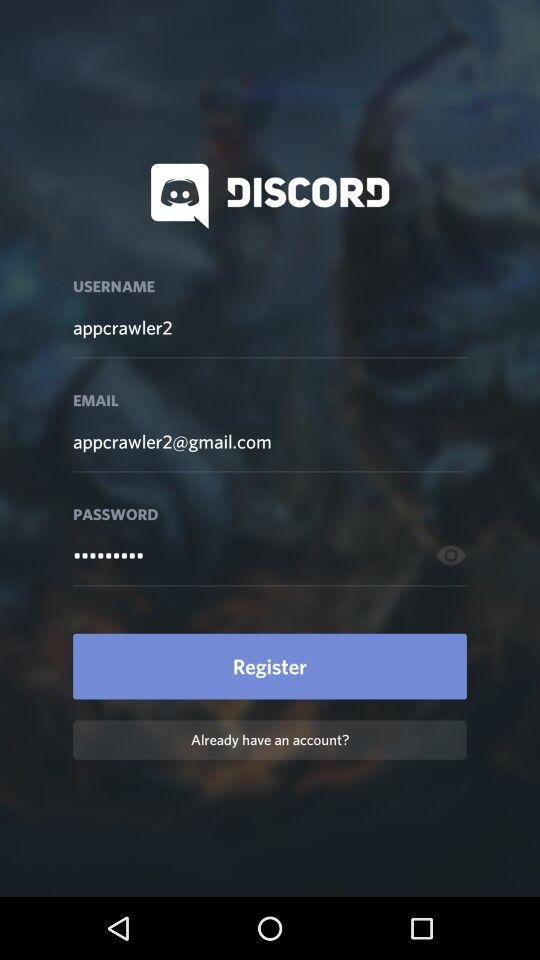What is the application name? The application name is "DISCORD". 